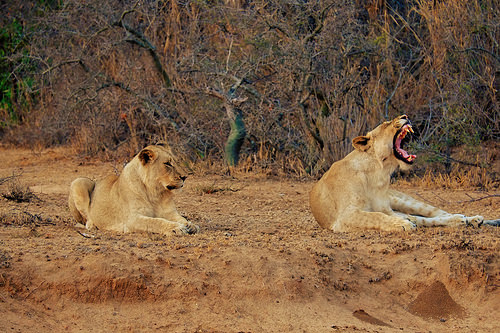<image>
Is there a yawning lion to the right of the laying lion? Yes. From this viewpoint, the yawning lion is positioned to the right side relative to the laying lion. 